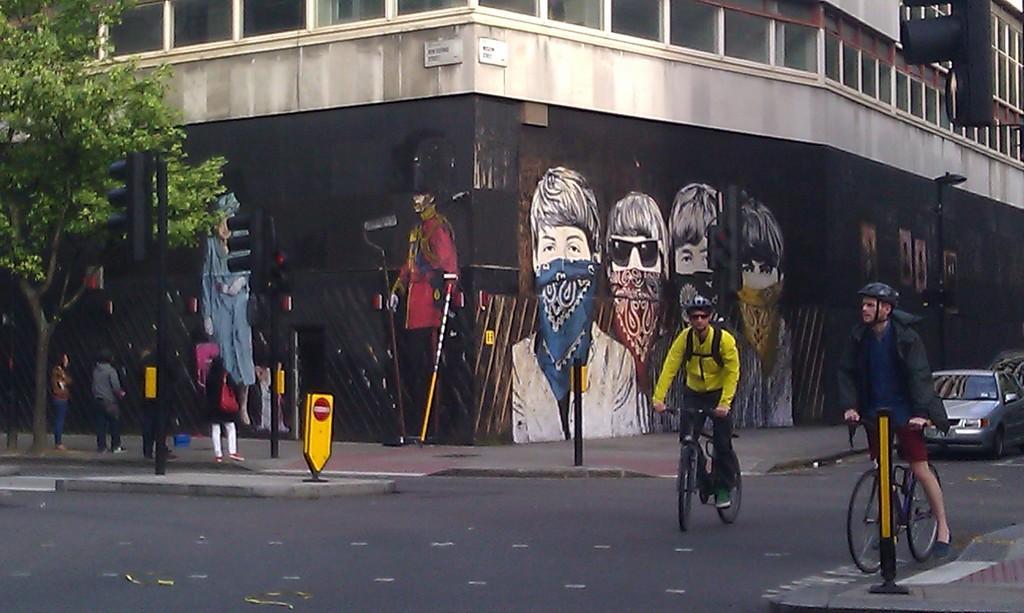In one or two sentences, can you explain what this image depicts? This is a picture taken on the road ,and back side there is a building ,on the building there is a art drawn and left side there a tree visible and there are some persons standing in front of the tree. and there are the two person riding bicycle on the road. 